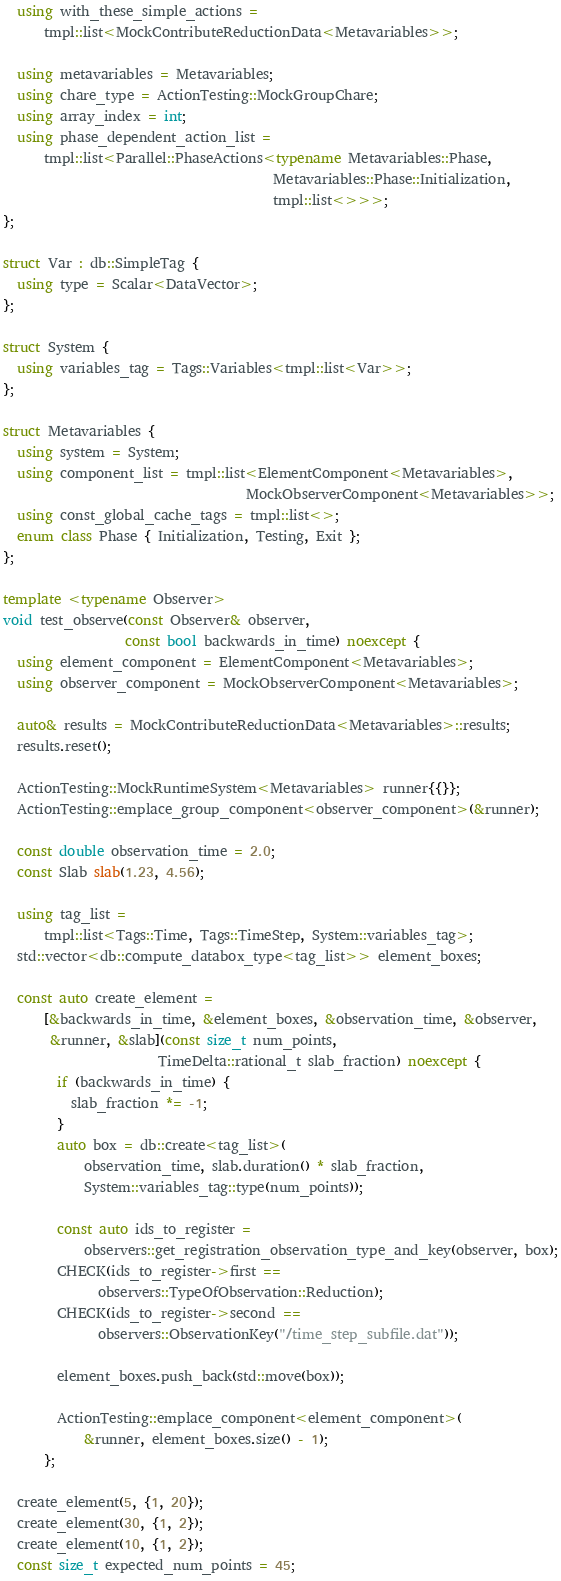Convert code to text. <code><loc_0><loc_0><loc_500><loc_500><_C++_>  using with_these_simple_actions =
      tmpl::list<MockContributeReductionData<Metavariables>>;

  using metavariables = Metavariables;
  using chare_type = ActionTesting::MockGroupChare;
  using array_index = int;
  using phase_dependent_action_list =
      tmpl::list<Parallel::PhaseActions<typename Metavariables::Phase,
                                        Metavariables::Phase::Initialization,
                                        tmpl::list<>>>;
};

struct Var : db::SimpleTag {
  using type = Scalar<DataVector>;
};

struct System {
  using variables_tag = Tags::Variables<tmpl::list<Var>>;
};

struct Metavariables {
  using system = System;
  using component_list = tmpl::list<ElementComponent<Metavariables>,
                                    MockObserverComponent<Metavariables>>;
  using const_global_cache_tags = tmpl::list<>;
  enum class Phase { Initialization, Testing, Exit };
};

template <typename Observer>
void test_observe(const Observer& observer,
                  const bool backwards_in_time) noexcept {
  using element_component = ElementComponent<Metavariables>;
  using observer_component = MockObserverComponent<Metavariables>;

  auto& results = MockContributeReductionData<Metavariables>::results;
  results.reset();

  ActionTesting::MockRuntimeSystem<Metavariables> runner{{}};
  ActionTesting::emplace_group_component<observer_component>(&runner);

  const double observation_time = 2.0;
  const Slab slab(1.23, 4.56);

  using tag_list =
      tmpl::list<Tags::Time, Tags::TimeStep, System::variables_tag>;
  std::vector<db::compute_databox_type<tag_list>> element_boxes;

  const auto create_element =
      [&backwards_in_time, &element_boxes, &observation_time, &observer,
       &runner, &slab](const size_t num_points,
                       TimeDelta::rational_t slab_fraction) noexcept {
        if (backwards_in_time) {
          slab_fraction *= -1;
        }
        auto box = db::create<tag_list>(
            observation_time, slab.duration() * slab_fraction,
            System::variables_tag::type(num_points));

        const auto ids_to_register =
            observers::get_registration_observation_type_and_key(observer, box);
        CHECK(ids_to_register->first ==
              observers::TypeOfObservation::Reduction);
        CHECK(ids_to_register->second ==
              observers::ObservationKey("/time_step_subfile.dat"));

        element_boxes.push_back(std::move(box));

        ActionTesting::emplace_component<element_component>(
            &runner, element_boxes.size() - 1);
      };

  create_element(5, {1, 20});
  create_element(30, {1, 2});
  create_element(10, {1, 2});
  const size_t expected_num_points = 45;</code> 